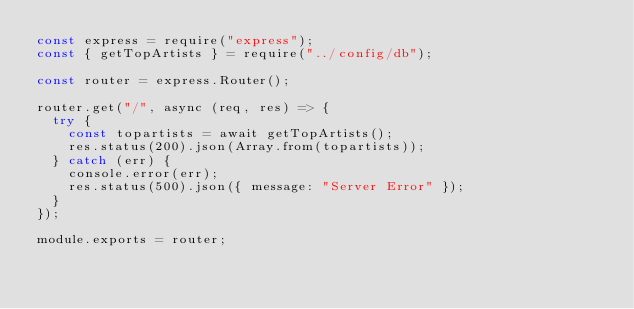Convert code to text. <code><loc_0><loc_0><loc_500><loc_500><_JavaScript_>const express = require("express");
const { getTopArtists } = require("../config/db");

const router = express.Router();

router.get("/", async (req, res) => {
  try {
    const topartists = await getTopArtists();
    res.status(200).json(Array.from(topartists));
  } catch (err) {
    console.error(err);
    res.status(500).json({ message: "Server Error" });
  }
});

module.exports = router;
</code> 